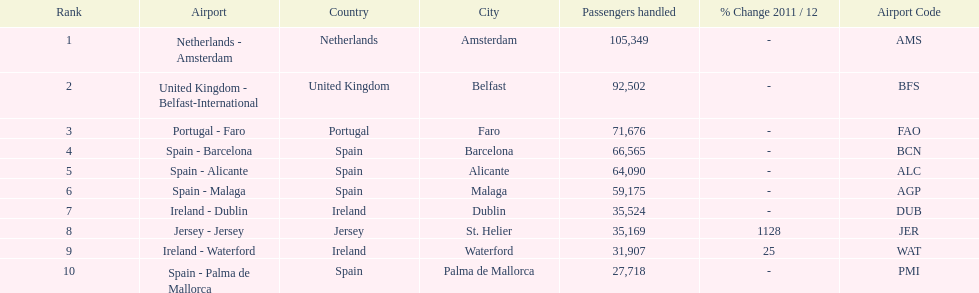Which airport has no more than 30,000 passengers handled among the 10 busiest routes to and from london southend airport in 2012? Spain - Palma de Mallorca. 